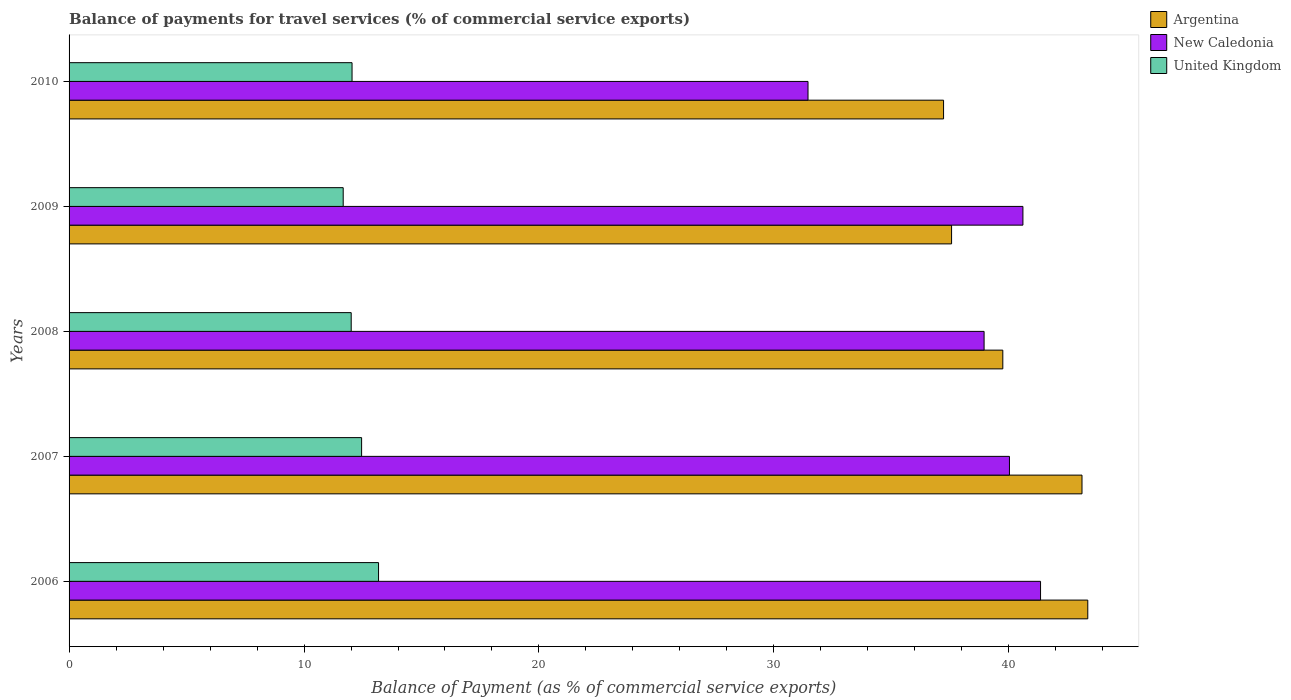How many groups of bars are there?
Your response must be concise. 5. Are the number of bars per tick equal to the number of legend labels?
Provide a succinct answer. Yes. Are the number of bars on each tick of the Y-axis equal?
Offer a very short reply. Yes. What is the label of the 5th group of bars from the top?
Your answer should be compact. 2006. In how many cases, is the number of bars for a given year not equal to the number of legend labels?
Provide a succinct answer. 0. What is the balance of payments for travel services in New Caledonia in 2007?
Offer a very short reply. 40.02. Across all years, what is the maximum balance of payments for travel services in United Kingdom?
Keep it short and to the point. 13.17. Across all years, what is the minimum balance of payments for travel services in Argentina?
Make the answer very short. 37.22. What is the total balance of payments for travel services in Argentina in the graph?
Your answer should be very brief. 200.99. What is the difference between the balance of payments for travel services in Argentina in 2008 and that in 2009?
Your answer should be compact. 2.18. What is the difference between the balance of payments for travel services in Argentina in 2008 and the balance of payments for travel services in United Kingdom in 2007?
Offer a very short reply. 27.29. What is the average balance of payments for travel services in United Kingdom per year?
Your answer should be compact. 12.27. In the year 2010, what is the difference between the balance of payments for travel services in Argentina and balance of payments for travel services in New Caledonia?
Provide a succinct answer. 5.77. In how many years, is the balance of payments for travel services in Argentina greater than 32 %?
Make the answer very short. 5. What is the ratio of the balance of payments for travel services in New Caledonia in 2009 to that in 2010?
Keep it short and to the point. 1.29. Is the difference between the balance of payments for travel services in Argentina in 2006 and 2010 greater than the difference between the balance of payments for travel services in New Caledonia in 2006 and 2010?
Make the answer very short. No. What is the difference between the highest and the second highest balance of payments for travel services in United Kingdom?
Keep it short and to the point. 0.72. What is the difference between the highest and the lowest balance of payments for travel services in United Kingdom?
Your answer should be compact. 1.5. What does the 3rd bar from the top in 2006 represents?
Offer a terse response. Argentina. What does the 3rd bar from the bottom in 2009 represents?
Offer a very short reply. United Kingdom. Is it the case that in every year, the sum of the balance of payments for travel services in United Kingdom and balance of payments for travel services in New Caledonia is greater than the balance of payments for travel services in Argentina?
Offer a very short reply. Yes. How many years are there in the graph?
Give a very brief answer. 5. What is the difference between two consecutive major ticks on the X-axis?
Your answer should be compact. 10. Does the graph contain any zero values?
Your answer should be very brief. No. Where does the legend appear in the graph?
Give a very brief answer. Top right. How many legend labels are there?
Provide a succinct answer. 3. How are the legend labels stacked?
Your answer should be compact. Vertical. What is the title of the graph?
Provide a succinct answer. Balance of payments for travel services (% of commercial service exports). Does "Togo" appear as one of the legend labels in the graph?
Your response must be concise. No. What is the label or title of the X-axis?
Provide a short and direct response. Balance of Payment (as % of commercial service exports). What is the Balance of Payment (as % of commercial service exports) in Argentina in 2006?
Your answer should be compact. 43.36. What is the Balance of Payment (as % of commercial service exports) in New Caledonia in 2006?
Offer a terse response. 41.35. What is the Balance of Payment (as % of commercial service exports) in United Kingdom in 2006?
Your answer should be very brief. 13.17. What is the Balance of Payment (as % of commercial service exports) in Argentina in 2007?
Your answer should be very brief. 43.11. What is the Balance of Payment (as % of commercial service exports) of New Caledonia in 2007?
Offer a very short reply. 40.02. What is the Balance of Payment (as % of commercial service exports) in United Kingdom in 2007?
Give a very brief answer. 12.45. What is the Balance of Payment (as % of commercial service exports) in Argentina in 2008?
Provide a succinct answer. 39.74. What is the Balance of Payment (as % of commercial service exports) in New Caledonia in 2008?
Your answer should be compact. 38.95. What is the Balance of Payment (as % of commercial service exports) of United Kingdom in 2008?
Your response must be concise. 12.01. What is the Balance of Payment (as % of commercial service exports) in Argentina in 2009?
Ensure brevity in your answer.  37.56. What is the Balance of Payment (as % of commercial service exports) in New Caledonia in 2009?
Give a very brief answer. 40.6. What is the Balance of Payment (as % of commercial service exports) of United Kingdom in 2009?
Provide a succinct answer. 11.67. What is the Balance of Payment (as % of commercial service exports) in Argentina in 2010?
Offer a very short reply. 37.22. What is the Balance of Payment (as % of commercial service exports) of New Caledonia in 2010?
Your answer should be very brief. 31.45. What is the Balance of Payment (as % of commercial service exports) of United Kingdom in 2010?
Offer a very short reply. 12.04. Across all years, what is the maximum Balance of Payment (as % of commercial service exports) in Argentina?
Your answer should be very brief. 43.36. Across all years, what is the maximum Balance of Payment (as % of commercial service exports) in New Caledonia?
Give a very brief answer. 41.35. Across all years, what is the maximum Balance of Payment (as % of commercial service exports) of United Kingdom?
Your answer should be compact. 13.17. Across all years, what is the minimum Balance of Payment (as % of commercial service exports) of Argentina?
Keep it short and to the point. 37.22. Across all years, what is the minimum Balance of Payment (as % of commercial service exports) of New Caledonia?
Your response must be concise. 31.45. Across all years, what is the minimum Balance of Payment (as % of commercial service exports) of United Kingdom?
Keep it short and to the point. 11.67. What is the total Balance of Payment (as % of commercial service exports) in Argentina in the graph?
Ensure brevity in your answer.  200.99. What is the total Balance of Payment (as % of commercial service exports) in New Caledonia in the graph?
Keep it short and to the point. 192.37. What is the total Balance of Payment (as % of commercial service exports) in United Kingdom in the graph?
Provide a short and direct response. 61.34. What is the difference between the Balance of Payment (as % of commercial service exports) of Argentina in 2006 and that in 2007?
Provide a short and direct response. 0.25. What is the difference between the Balance of Payment (as % of commercial service exports) of New Caledonia in 2006 and that in 2007?
Offer a very short reply. 1.32. What is the difference between the Balance of Payment (as % of commercial service exports) of United Kingdom in 2006 and that in 2007?
Ensure brevity in your answer.  0.72. What is the difference between the Balance of Payment (as % of commercial service exports) in Argentina in 2006 and that in 2008?
Ensure brevity in your answer.  3.62. What is the difference between the Balance of Payment (as % of commercial service exports) of New Caledonia in 2006 and that in 2008?
Your answer should be very brief. 2.4. What is the difference between the Balance of Payment (as % of commercial service exports) of United Kingdom in 2006 and that in 2008?
Ensure brevity in your answer.  1.16. What is the difference between the Balance of Payment (as % of commercial service exports) of Argentina in 2006 and that in 2009?
Give a very brief answer. 5.8. What is the difference between the Balance of Payment (as % of commercial service exports) of New Caledonia in 2006 and that in 2009?
Offer a terse response. 0.75. What is the difference between the Balance of Payment (as % of commercial service exports) of United Kingdom in 2006 and that in 2009?
Provide a short and direct response. 1.5. What is the difference between the Balance of Payment (as % of commercial service exports) of Argentina in 2006 and that in 2010?
Give a very brief answer. 6.14. What is the difference between the Balance of Payment (as % of commercial service exports) in New Caledonia in 2006 and that in 2010?
Keep it short and to the point. 9.9. What is the difference between the Balance of Payment (as % of commercial service exports) of United Kingdom in 2006 and that in 2010?
Your response must be concise. 1.13. What is the difference between the Balance of Payment (as % of commercial service exports) in Argentina in 2007 and that in 2008?
Offer a very short reply. 3.37. What is the difference between the Balance of Payment (as % of commercial service exports) in New Caledonia in 2007 and that in 2008?
Offer a terse response. 1.08. What is the difference between the Balance of Payment (as % of commercial service exports) in United Kingdom in 2007 and that in 2008?
Ensure brevity in your answer.  0.44. What is the difference between the Balance of Payment (as % of commercial service exports) of Argentina in 2007 and that in 2009?
Your answer should be compact. 5.55. What is the difference between the Balance of Payment (as % of commercial service exports) of New Caledonia in 2007 and that in 2009?
Keep it short and to the point. -0.57. What is the difference between the Balance of Payment (as % of commercial service exports) of United Kingdom in 2007 and that in 2009?
Offer a very short reply. 0.78. What is the difference between the Balance of Payment (as % of commercial service exports) in Argentina in 2007 and that in 2010?
Make the answer very short. 5.89. What is the difference between the Balance of Payment (as % of commercial service exports) of New Caledonia in 2007 and that in 2010?
Offer a terse response. 8.57. What is the difference between the Balance of Payment (as % of commercial service exports) of United Kingdom in 2007 and that in 2010?
Provide a succinct answer. 0.41. What is the difference between the Balance of Payment (as % of commercial service exports) of Argentina in 2008 and that in 2009?
Offer a very short reply. 2.18. What is the difference between the Balance of Payment (as % of commercial service exports) in New Caledonia in 2008 and that in 2009?
Provide a short and direct response. -1.65. What is the difference between the Balance of Payment (as % of commercial service exports) in United Kingdom in 2008 and that in 2009?
Your answer should be compact. 0.34. What is the difference between the Balance of Payment (as % of commercial service exports) in Argentina in 2008 and that in 2010?
Make the answer very short. 2.52. What is the difference between the Balance of Payment (as % of commercial service exports) of New Caledonia in 2008 and that in 2010?
Your answer should be very brief. 7.49. What is the difference between the Balance of Payment (as % of commercial service exports) in United Kingdom in 2008 and that in 2010?
Offer a very short reply. -0.04. What is the difference between the Balance of Payment (as % of commercial service exports) in Argentina in 2009 and that in 2010?
Provide a short and direct response. 0.34. What is the difference between the Balance of Payment (as % of commercial service exports) of New Caledonia in 2009 and that in 2010?
Make the answer very short. 9.15. What is the difference between the Balance of Payment (as % of commercial service exports) of United Kingdom in 2009 and that in 2010?
Make the answer very short. -0.38. What is the difference between the Balance of Payment (as % of commercial service exports) in Argentina in 2006 and the Balance of Payment (as % of commercial service exports) in New Caledonia in 2007?
Make the answer very short. 3.33. What is the difference between the Balance of Payment (as % of commercial service exports) of Argentina in 2006 and the Balance of Payment (as % of commercial service exports) of United Kingdom in 2007?
Ensure brevity in your answer.  30.91. What is the difference between the Balance of Payment (as % of commercial service exports) in New Caledonia in 2006 and the Balance of Payment (as % of commercial service exports) in United Kingdom in 2007?
Ensure brevity in your answer.  28.9. What is the difference between the Balance of Payment (as % of commercial service exports) in Argentina in 2006 and the Balance of Payment (as % of commercial service exports) in New Caledonia in 2008?
Your answer should be compact. 4.41. What is the difference between the Balance of Payment (as % of commercial service exports) of Argentina in 2006 and the Balance of Payment (as % of commercial service exports) of United Kingdom in 2008?
Ensure brevity in your answer.  31.35. What is the difference between the Balance of Payment (as % of commercial service exports) in New Caledonia in 2006 and the Balance of Payment (as % of commercial service exports) in United Kingdom in 2008?
Your answer should be compact. 29.34. What is the difference between the Balance of Payment (as % of commercial service exports) of Argentina in 2006 and the Balance of Payment (as % of commercial service exports) of New Caledonia in 2009?
Your answer should be very brief. 2.76. What is the difference between the Balance of Payment (as % of commercial service exports) of Argentina in 2006 and the Balance of Payment (as % of commercial service exports) of United Kingdom in 2009?
Keep it short and to the point. 31.69. What is the difference between the Balance of Payment (as % of commercial service exports) of New Caledonia in 2006 and the Balance of Payment (as % of commercial service exports) of United Kingdom in 2009?
Your answer should be compact. 29.68. What is the difference between the Balance of Payment (as % of commercial service exports) in Argentina in 2006 and the Balance of Payment (as % of commercial service exports) in New Caledonia in 2010?
Offer a very short reply. 11.91. What is the difference between the Balance of Payment (as % of commercial service exports) in Argentina in 2006 and the Balance of Payment (as % of commercial service exports) in United Kingdom in 2010?
Your answer should be very brief. 31.31. What is the difference between the Balance of Payment (as % of commercial service exports) of New Caledonia in 2006 and the Balance of Payment (as % of commercial service exports) of United Kingdom in 2010?
Offer a very short reply. 29.3. What is the difference between the Balance of Payment (as % of commercial service exports) in Argentina in 2007 and the Balance of Payment (as % of commercial service exports) in New Caledonia in 2008?
Provide a succinct answer. 4.17. What is the difference between the Balance of Payment (as % of commercial service exports) of Argentina in 2007 and the Balance of Payment (as % of commercial service exports) of United Kingdom in 2008?
Your response must be concise. 31.1. What is the difference between the Balance of Payment (as % of commercial service exports) of New Caledonia in 2007 and the Balance of Payment (as % of commercial service exports) of United Kingdom in 2008?
Provide a short and direct response. 28.02. What is the difference between the Balance of Payment (as % of commercial service exports) of Argentina in 2007 and the Balance of Payment (as % of commercial service exports) of New Caledonia in 2009?
Ensure brevity in your answer.  2.51. What is the difference between the Balance of Payment (as % of commercial service exports) in Argentina in 2007 and the Balance of Payment (as % of commercial service exports) in United Kingdom in 2009?
Your answer should be compact. 31.44. What is the difference between the Balance of Payment (as % of commercial service exports) of New Caledonia in 2007 and the Balance of Payment (as % of commercial service exports) of United Kingdom in 2009?
Make the answer very short. 28.36. What is the difference between the Balance of Payment (as % of commercial service exports) in Argentina in 2007 and the Balance of Payment (as % of commercial service exports) in New Caledonia in 2010?
Your response must be concise. 11.66. What is the difference between the Balance of Payment (as % of commercial service exports) in Argentina in 2007 and the Balance of Payment (as % of commercial service exports) in United Kingdom in 2010?
Your response must be concise. 31.07. What is the difference between the Balance of Payment (as % of commercial service exports) in New Caledonia in 2007 and the Balance of Payment (as % of commercial service exports) in United Kingdom in 2010?
Your answer should be compact. 27.98. What is the difference between the Balance of Payment (as % of commercial service exports) of Argentina in 2008 and the Balance of Payment (as % of commercial service exports) of New Caledonia in 2009?
Your answer should be compact. -0.86. What is the difference between the Balance of Payment (as % of commercial service exports) in Argentina in 2008 and the Balance of Payment (as % of commercial service exports) in United Kingdom in 2009?
Make the answer very short. 28.07. What is the difference between the Balance of Payment (as % of commercial service exports) in New Caledonia in 2008 and the Balance of Payment (as % of commercial service exports) in United Kingdom in 2009?
Your answer should be very brief. 27.28. What is the difference between the Balance of Payment (as % of commercial service exports) in Argentina in 2008 and the Balance of Payment (as % of commercial service exports) in New Caledonia in 2010?
Your response must be concise. 8.29. What is the difference between the Balance of Payment (as % of commercial service exports) in Argentina in 2008 and the Balance of Payment (as % of commercial service exports) in United Kingdom in 2010?
Offer a very short reply. 27.7. What is the difference between the Balance of Payment (as % of commercial service exports) of New Caledonia in 2008 and the Balance of Payment (as % of commercial service exports) of United Kingdom in 2010?
Keep it short and to the point. 26.9. What is the difference between the Balance of Payment (as % of commercial service exports) in Argentina in 2009 and the Balance of Payment (as % of commercial service exports) in New Caledonia in 2010?
Make the answer very short. 6.11. What is the difference between the Balance of Payment (as % of commercial service exports) of Argentina in 2009 and the Balance of Payment (as % of commercial service exports) of United Kingdom in 2010?
Give a very brief answer. 25.52. What is the difference between the Balance of Payment (as % of commercial service exports) in New Caledonia in 2009 and the Balance of Payment (as % of commercial service exports) in United Kingdom in 2010?
Provide a succinct answer. 28.55. What is the average Balance of Payment (as % of commercial service exports) in Argentina per year?
Provide a short and direct response. 40.2. What is the average Balance of Payment (as % of commercial service exports) in New Caledonia per year?
Provide a short and direct response. 38.47. What is the average Balance of Payment (as % of commercial service exports) of United Kingdom per year?
Ensure brevity in your answer.  12.27. In the year 2006, what is the difference between the Balance of Payment (as % of commercial service exports) of Argentina and Balance of Payment (as % of commercial service exports) of New Caledonia?
Your response must be concise. 2.01. In the year 2006, what is the difference between the Balance of Payment (as % of commercial service exports) in Argentina and Balance of Payment (as % of commercial service exports) in United Kingdom?
Your response must be concise. 30.19. In the year 2006, what is the difference between the Balance of Payment (as % of commercial service exports) of New Caledonia and Balance of Payment (as % of commercial service exports) of United Kingdom?
Keep it short and to the point. 28.18. In the year 2007, what is the difference between the Balance of Payment (as % of commercial service exports) of Argentina and Balance of Payment (as % of commercial service exports) of New Caledonia?
Provide a short and direct response. 3.09. In the year 2007, what is the difference between the Balance of Payment (as % of commercial service exports) in Argentina and Balance of Payment (as % of commercial service exports) in United Kingdom?
Provide a succinct answer. 30.66. In the year 2007, what is the difference between the Balance of Payment (as % of commercial service exports) in New Caledonia and Balance of Payment (as % of commercial service exports) in United Kingdom?
Keep it short and to the point. 27.57. In the year 2008, what is the difference between the Balance of Payment (as % of commercial service exports) of Argentina and Balance of Payment (as % of commercial service exports) of New Caledonia?
Provide a succinct answer. 0.8. In the year 2008, what is the difference between the Balance of Payment (as % of commercial service exports) in Argentina and Balance of Payment (as % of commercial service exports) in United Kingdom?
Your response must be concise. 27.73. In the year 2008, what is the difference between the Balance of Payment (as % of commercial service exports) in New Caledonia and Balance of Payment (as % of commercial service exports) in United Kingdom?
Provide a short and direct response. 26.94. In the year 2009, what is the difference between the Balance of Payment (as % of commercial service exports) in Argentina and Balance of Payment (as % of commercial service exports) in New Caledonia?
Your response must be concise. -3.04. In the year 2009, what is the difference between the Balance of Payment (as % of commercial service exports) of Argentina and Balance of Payment (as % of commercial service exports) of United Kingdom?
Your answer should be compact. 25.89. In the year 2009, what is the difference between the Balance of Payment (as % of commercial service exports) of New Caledonia and Balance of Payment (as % of commercial service exports) of United Kingdom?
Your answer should be compact. 28.93. In the year 2010, what is the difference between the Balance of Payment (as % of commercial service exports) in Argentina and Balance of Payment (as % of commercial service exports) in New Caledonia?
Offer a very short reply. 5.77. In the year 2010, what is the difference between the Balance of Payment (as % of commercial service exports) in Argentina and Balance of Payment (as % of commercial service exports) in United Kingdom?
Provide a short and direct response. 25.18. In the year 2010, what is the difference between the Balance of Payment (as % of commercial service exports) in New Caledonia and Balance of Payment (as % of commercial service exports) in United Kingdom?
Offer a terse response. 19.41. What is the ratio of the Balance of Payment (as % of commercial service exports) in New Caledonia in 2006 to that in 2007?
Keep it short and to the point. 1.03. What is the ratio of the Balance of Payment (as % of commercial service exports) of United Kingdom in 2006 to that in 2007?
Keep it short and to the point. 1.06. What is the ratio of the Balance of Payment (as % of commercial service exports) of Argentina in 2006 to that in 2008?
Make the answer very short. 1.09. What is the ratio of the Balance of Payment (as % of commercial service exports) in New Caledonia in 2006 to that in 2008?
Keep it short and to the point. 1.06. What is the ratio of the Balance of Payment (as % of commercial service exports) of United Kingdom in 2006 to that in 2008?
Ensure brevity in your answer.  1.1. What is the ratio of the Balance of Payment (as % of commercial service exports) of Argentina in 2006 to that in 2009?
Ensure brevity in your answer.  1.15. What is the ratio of the Balance of Payment (as % of commercial service exports) in New Caledonia in 2006 to that in 2009?
Offer a terse response. 1.02. What is the ratio of the Balance of Payment (as % of commercial service exports) in United Kingdom in 2006 to that in 2009?
Provide a short and direct response. 1.13. What is the ratio of the Balance of Payment (as % of commercial service exports) of Argentina in 2006 to that in 2010?
Provide a short and direct response. 1.16. What is the ratio of the Balance of Payment (as % of commercial service exports) in New Caledonia in 2006 to that in 2010?
Provide a short and direct response. 1.31. What is the ratio of the Balance of Payment (as % of commercial service exports) in United Kingdom in 2006 to that in 2010?
Your response must be concise. 1.09. What is the ratio of the Balance of Payment (as % of commercial service exports) in Argentina in 2007 to that in 2008?
Offer a very short reply. 1.08. What is the ratio of the Balance of Payment (as % of commercial service exports) in New Caledonia in 2007 to that in 2008?
Provide a short and direct response. 1.03. What is the ratio of the Balance of Payment (as % of commercial service exports) in United Kingdom in 2007 to that in 2008?
Your answer should be very brief. 1.04. What is the ratio of the Balance of Payment (as % of commercial service exports) of Argentina in 2007 to that in 2009?
Ensure brevity in your answer.  1.15. What is the ratio of the Balance of Payment (as % of commercial service exports) in New Caledonia in 2007 to that in 2009?
Ensure brevity in your answer.  0.99. What is the ratio of the Balance of Payment (as % of commercial service exports) in United Kingdom in 2007 to that in 2009?
Make the answer very short. 1.07. What is the ratio of the Balance of Payment (as % of commercial service exports) in Argentina in 2007 to that in 2010?
Your answer should be very brief. 1.16. What is the ratio of the Balance of Payment (as % of commercial service exports) of New Caledonia in 2007 to that in 2010?
Your response must be concise. 1.27. What is the ratio of the Balance of Payment (as % of commercial service exports) in United Kingdom in 2007 to that in 2010?
Provide a succinct answer. 1.03. What is the ratio of the Balance of Payment (as % of commercial service exports) of Argentina in 2008 to that in 2009?
Provide a succinct answer. 1.06. What is the ratio of the Balance of Payment (as % of commercial service exports) in New Caledonia in 2008 to that in 2009?
Your answer should be compact. 0.96. What is the ratio of the Balance of Payment (as % of commercial service exports) of United Kingdom in 2008 to that in 2009?
Offer a very short reply. 1.03. What is the ratio of the Balance of Payment (as % of commercial service exports) in Argentina in 2008 to that in 2010?
Offer a terse response. 1.07. What is the ratio of the Balance of Payment (as % of commercial service exports) of New Caledonia in 2008 to that in 2010?
Provide a succinct answer. 1.24. What is the ratio of the Balance of Payment (as % of commercial service exports) of United Kingdom in 2008 to that in 2010?
Make the answer very short. 1. What is the ratio of the Balance of Payment (as % of commercial service exports) in Argentina in 2009 to that in 2010?
Make the answer very short. 1.01. What is the ratio of the Balance of Payment (as % of commercial service exports) of New Caledonia in 2009 to that in 2010?
Give a very brief answer. 1.29. What is the ratio of the Balance of Payment (as % of commercial service exports) in United Kingdom in 2009 to that in 2010?
Ensure brevity in your answer.  0.97. What is the difference between the highest and the second highest Balance of Payment (as % of commercial service exports) of Argentina?
Your response must be concise. 0.25. What is the difference between the highest and the second highest Balance of Payment (as % of commercial service exports) in New Caledonia?
Provide a short and direct response. 0.75. What is the difference between the highest and the second highest Balance of Payment (as % of commercial service exports) of United Kingdom?
Keep it short and to the point. 0.72. What is the difference between the highest and the lowest Balance of Payment (as % of commercial service exports) of Argentina?
Provide a short and direct response. 6.14. What is the difference between the highest and the lowest Balance of Payment (as % of commercial service exports) of New Caledonia?
Give a very brief answer. 9.9. What is the difference between the highest and the lowest Balance of Payment (as % of commercial service exports) of United Kingdom?
Make the answer very short. 1.5. 